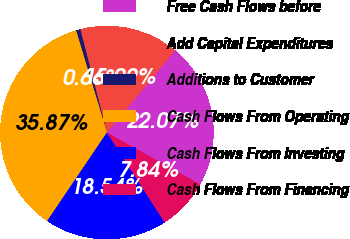Convert chart to OTSL. <chart><loc_0><loc_0><loc_500><loc_500><pie_chart><fcel>Free Cash Flows before<fcel>Add Capital Expenditures<fcel>Additions to Customer<fcel>Cash Flows From Operating<fcel>Cash Flows From Investing<fcel>Cash Flows From Financing<nl><fcel>22.07%<fcel>15.02%<fcel>0.66%<fcel>35.87%<fcel>18.54%<fcel>7.84%<nl></chart> 